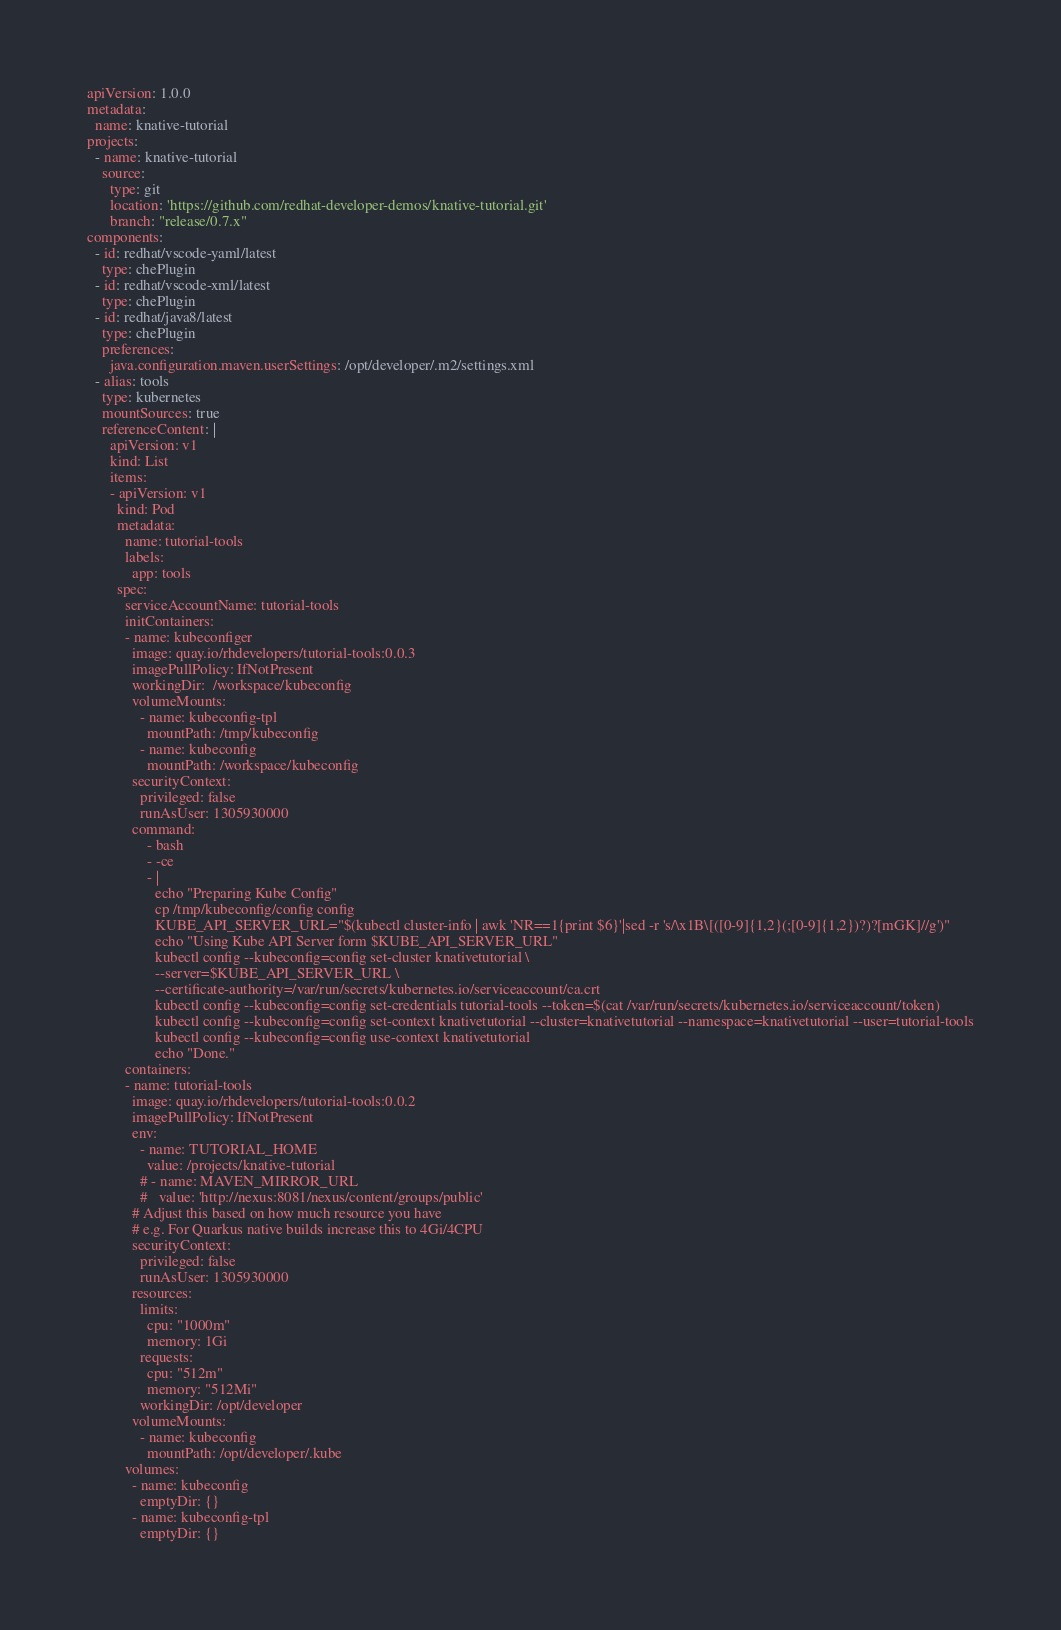Convert code to text. <code><loc_0><loc_0><loc_500><loc_500><_YAML_>apiVersion: 1.0.0
metadata:
  name: knative-tutorial
projects:
  - name: knative-tutorial
    source:
      type: git
      location: 'https://github.com/redhat-developer-demos/knative-tutorial.git'
      branch: "release/0.7.x"
components:
  - id: redhat/vscode-yaml/latest
    type: chePlugin
  - id: redhat/vscode-xml/latest
    type: chePlugin
  - id: redhat/java8/latest
    type: chePlugin
    preferences:
      java.configuration.maven.userSettings: /opt/developer/.m2/settings.xml
  - alias: tools
    type: kubernetes
    mountSources: true
    referenceContent: |
      apiVersion: v1
      kind: List
      items:
      - apiVersion: v1
        kind: Pod
        metadata:
          name: tutorial-tools
          labels:
            app: tools
        spec:
          serviceAccountName: tutorial-tools
          initContainers:
          - name: kubeconfiger
            image: quay.io/rhdevelopers/tutorial-tools:0.0.3
            imagePullPolicy: IfNotPresent
            workingDir:  /workspace/kubeconfig   
            volumeMounts:
              - name: kubeconfig-tpl
                mountPath: /tmp/kubeconfig
              - name: kubeconfig
                mountPath: /workspace/kubeconfig             
            securityContext:
              privileged: false
              runAsUser: 1305930000
            command:
                - bash
                - -ce
                - |
                  echo "Preparing Kube Config" 
                  cp /tmp/kubeconfig/config config
                  KUBE_API_SERVER_URL="$(kubectl cluster-info | awk 'NR==1{print $6}'|sed -r 's/\x1B\[([0-9]{1,2}(;[0-9]{1,2})?)?[mGK]//g')"
                  echo "Using Kube API Server form $KUBE_API_SERVER_URL"
                  kubectl config --kubeconfig=config set-cluster knativetutorial \
                  --server=$KUBE_API_SERVER_URL \
                  --certificate-authority=/var/run/secrets/kubernetes.io/serviceaccount/ca.crt
                  kubectl config --kubeconfig=config set-credentials tutorial-tools --token=$(cat /var/run/secrets/kubernetes.io/serviceaccount/token)
                  kubectl config --kubeconfig=config set-context knativetutorial --cluster=knativetutorial --namespace=knativetutorial --user=tutorial-tools
                  kubectl config --kubeconfig=config use-context knativetutorial
                  echo "Done."
          containers:
          - name: tutorial-tools
            image: quay.io/rhdevelopers/tutorial-tools:0.0.2
            imagePullPolicy: IfNotPresent
            env:
              - name: TUTORIAL_HOME
                value: /projects/knative-tutorial
              # - name: MAVEN_MIRROR_URL
              #   value: 'http://nexus:8081/nexus/content/groups/public'
            # Adjust this based on how much resource you have
            # e.g. For Quarkus native builds increase this to 4Gi/4CPU
            securityContext:
              privileged: false
              runAsUser: 1305930000
            resources:
              limits: 
                cpu: "1000m"
                memory: 1Gi
              requests:
                cpu: "512m"
                memory: "512Mi"
              workingDir: /opt/developer
            volumeMounts:
              - name: kubeconfig
                mountPath: /opt/developer/.kube
          volumes:
            - name: kubeconfig
              emptyDir: {}
            - name: kubeconfig-tpl
              emptyDir: {}
</code> 